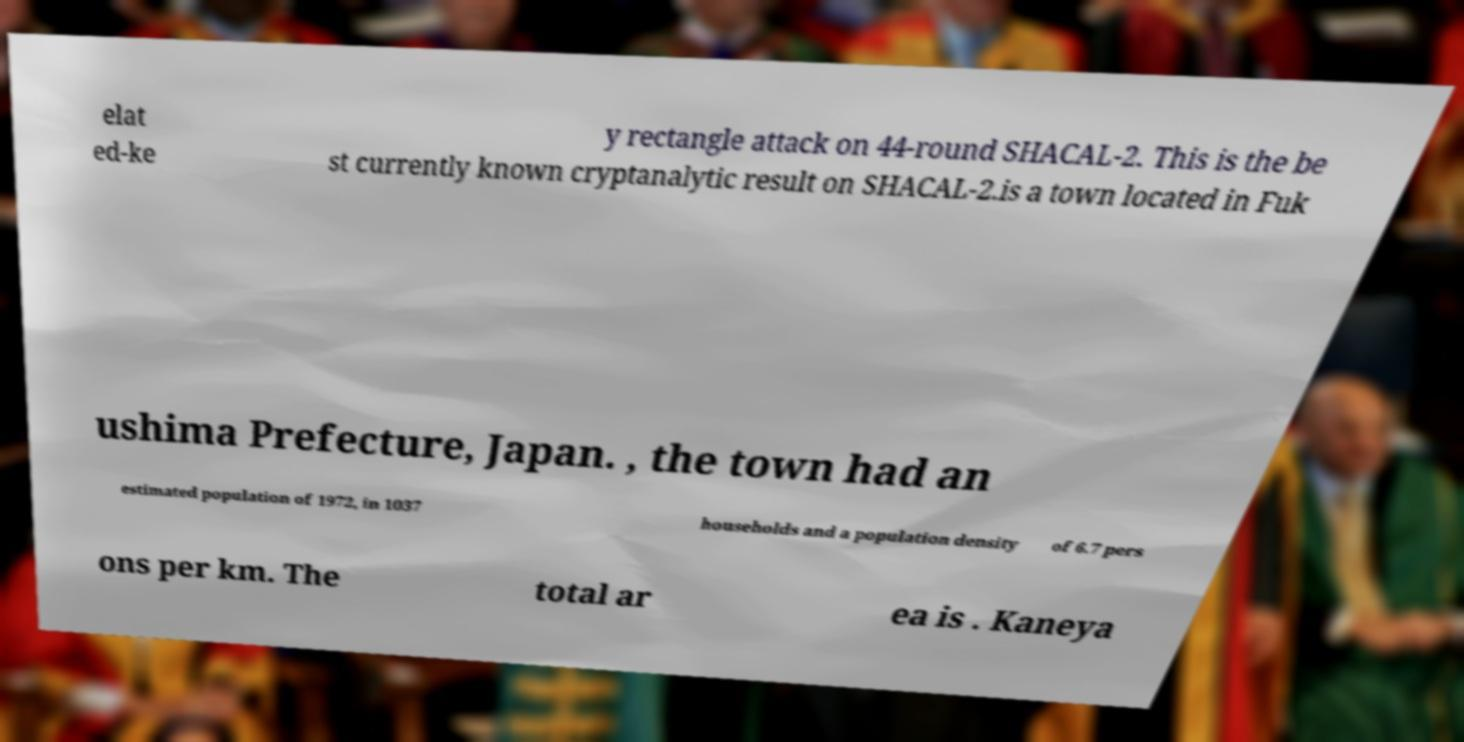There's text embedded in this image that I need extracted. Can you transcribe it verbatim? elat ed-ke y rectangle attack on 44-round SHACAL-2. This is the be st currently known cryptanalytic result on SHACAL-2.is a town located in Fuk ushima Prefecture, Japan. , the town had an estimated population of 1972, in 1037 households and a population density of 6.7 pers ons per km. The total ar ea is . Kaneya 